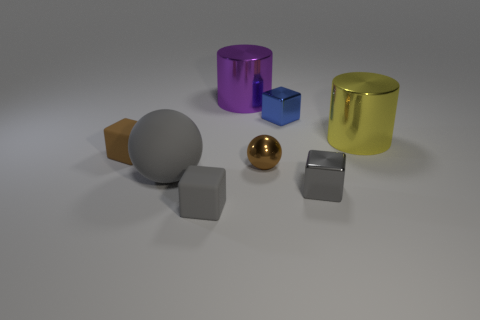Looking at the arrangement and lighting of the objects, what sort of atmosphere or context do you think this image reflects? The image features an understated and controlled arrangement of geometric objects with soft illumination, conveying a sense of minimalist design. This controlled setting, with diffused lighting and shadow play, might suggest a product display or a 3D composition intended to focus attention on the form and material properties of the objects. The neutral background smoothly complements the scene, emphasizing the objects without distraction, ideal for showcasing design elements or for educational purposes to study geometry and light interactions. 